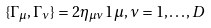Convert formula to latex. <formula><loc_0><loc_0><loc_500><loc_500>\{ \Gamma _ { \mu } , \Gamma _ { \nu } \} = 2 \eta _ { \mu \nu } { 1 } \, \mu , \nu = 1 , \dots , D</formula> 